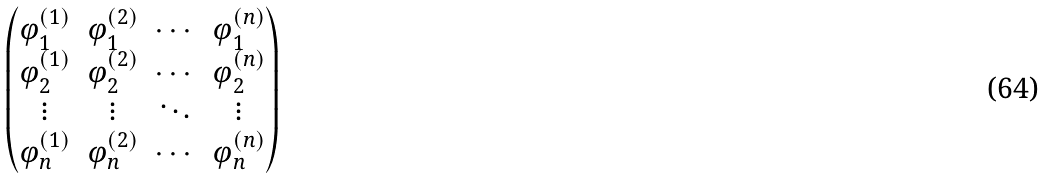<formula> <loc_0><loc_0><loc_500><loc_500>\begin{pmatrix} \varphi _ { 1 } ^ { ( 1 ) } & \varphi _ { 1 } ^ { ( 2 ) } & \cdots & \varphi _ { 1 } ^ { ( n ) } \\ \varphi _ { 2 } ^ { ( 1 ) } & \varphi _ { 2 } ^ { ( 2 ) } & \cdots & \varphi _ { 2 } ^ { ( n ) } \\ \vdots & \vdots & \ddots & \vdots \\ \varphi _ { n } ^ { ( 1 ) } & \varphi _ { n } ^ { ( 2 ) } & \cdots & \varphi _ { n } ^ { ( n ) } \\ \end{pmatrix}</formula> 